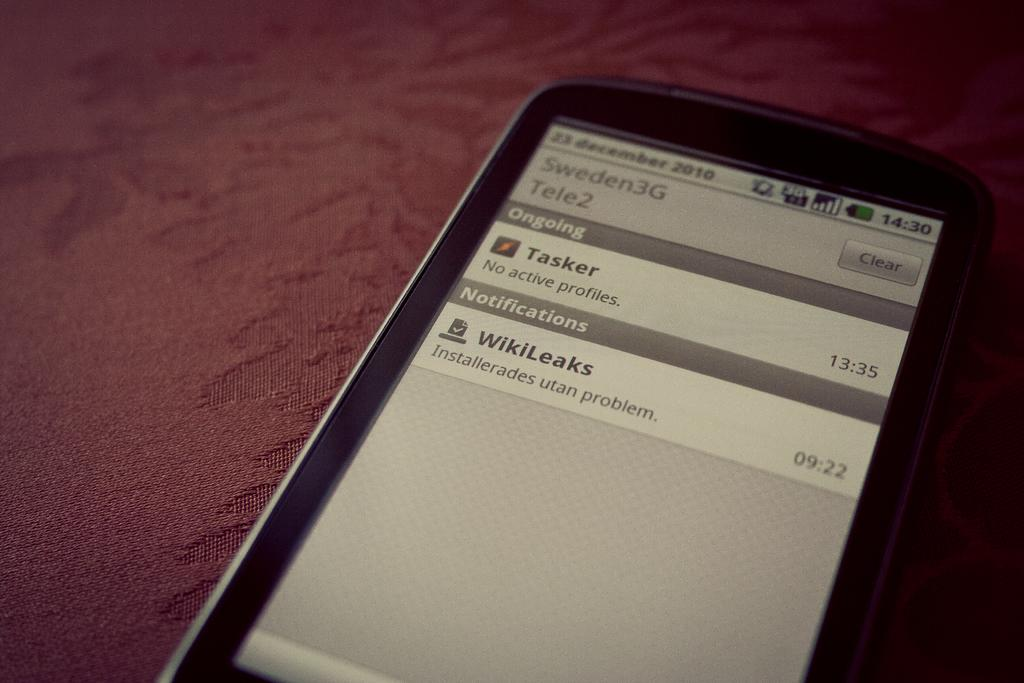What color is the cloth in the image? The cloth in the image is maroon-colored. What object is placed on the cloth? There is a black-colored phone on the cloth. What can be seen on the phone's screen? The phone's screen displays some written content. Can you describe the ocean visible in the image? There is no ocean present in the image; it features a maroon-colored cloth with a black phone on it. What type of stitch is used to create the cloth in the image? The provided facts do not mention any details about the stitch used to create the cloth, so we cannot determine that information from the image. 